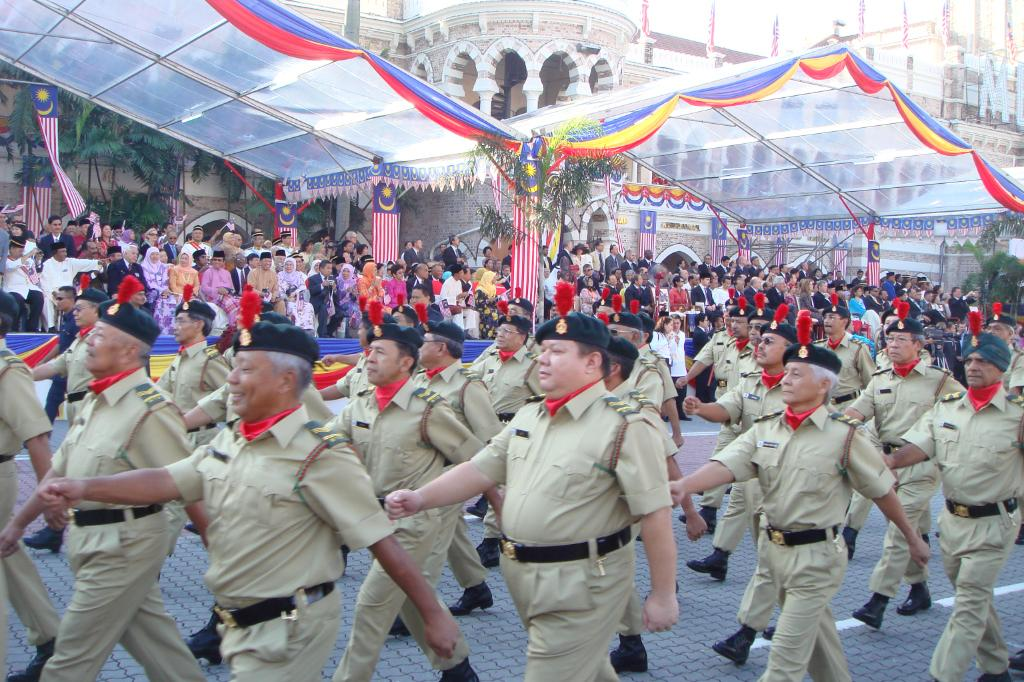What type of people can be seen in the image? There are police officers in the image. What are the police officers doing in the image? The police officers are marching on the road. Are there any other people present in the image besides the police officers? Yes, there are people sitting in the middle of the road. Can you tell me what request the uncle made in the image? There is no uncle present in the image, so it is not possible to answer that question. 